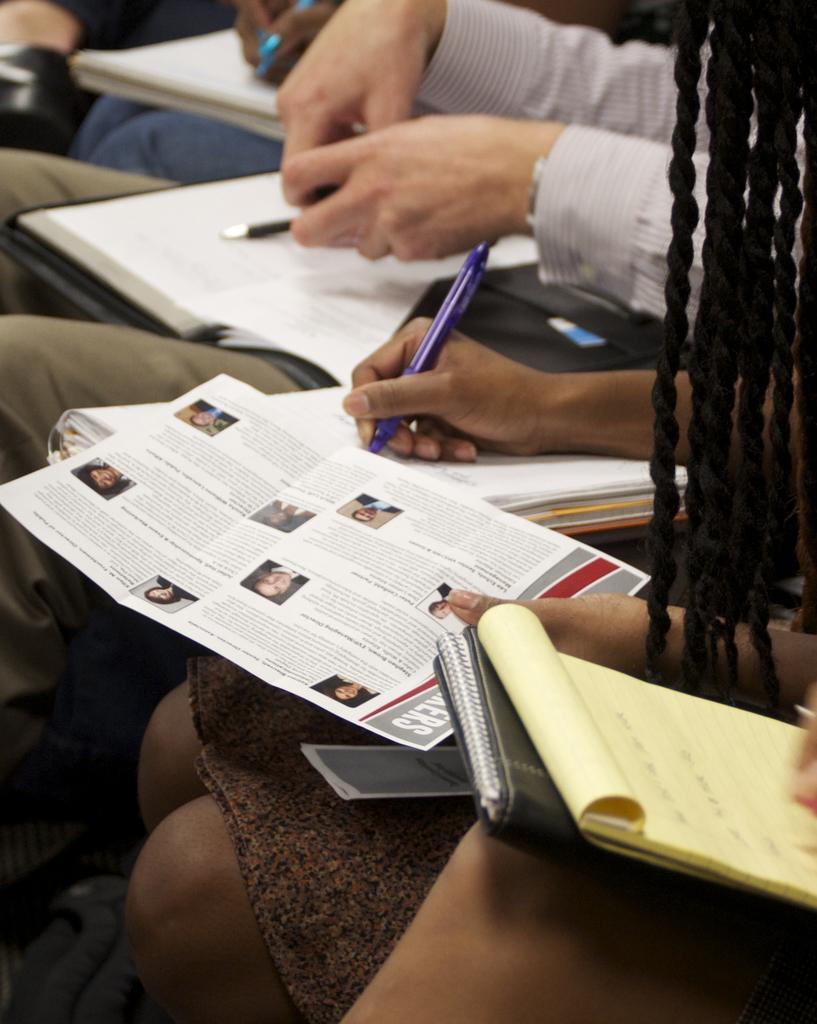In one or two sentences, can you explain what this image depicts? In this image, on the right there are people, they are sitting, they are holding books, pens, posters. 